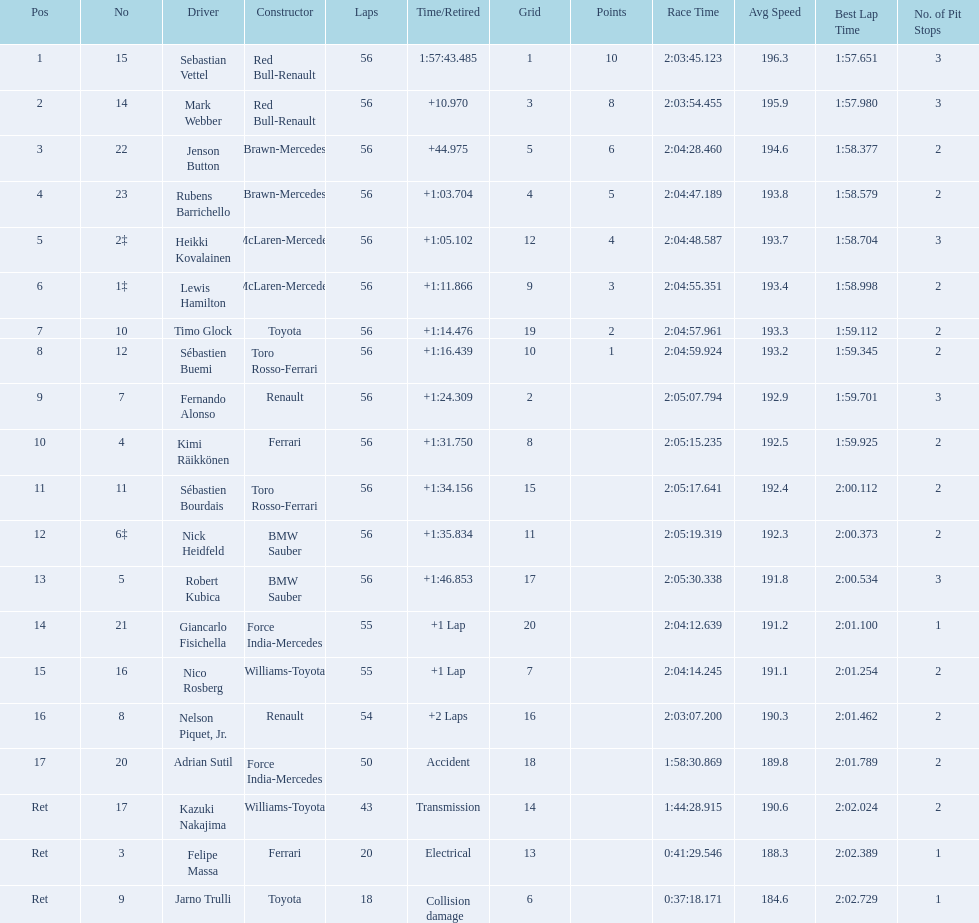Who was the slowest driver to finish the race? Robert Kubica. 